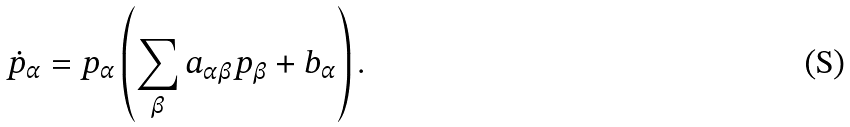<formula> <loc_0><loc_0><loc_500><loc_500>\dot { p } _ { \alpha } = p _ { \alpha } \left ( \sum _ { \beta } a _ { \alpha \beta } p _ { \beta } + b _ { \alpha } \right ) .</formula> 